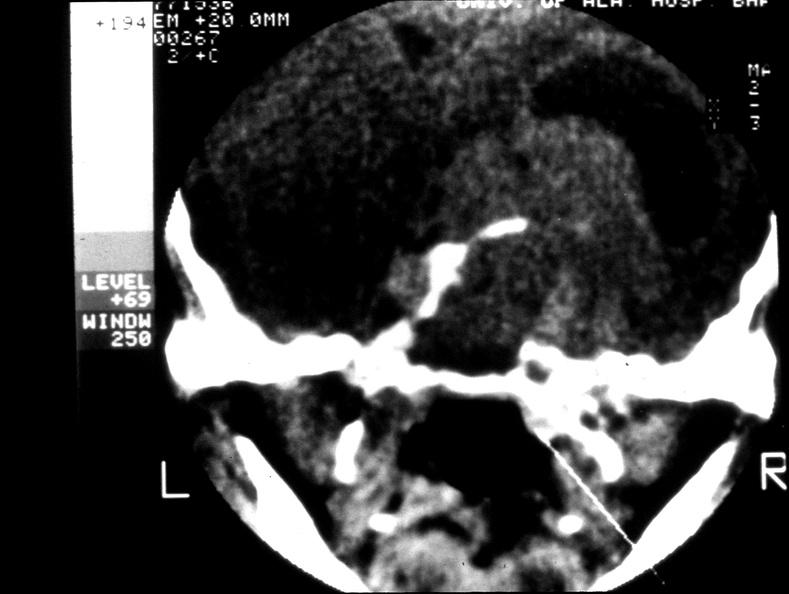what does this image show?
Answer the question using a single word or phrase. Pituitary 